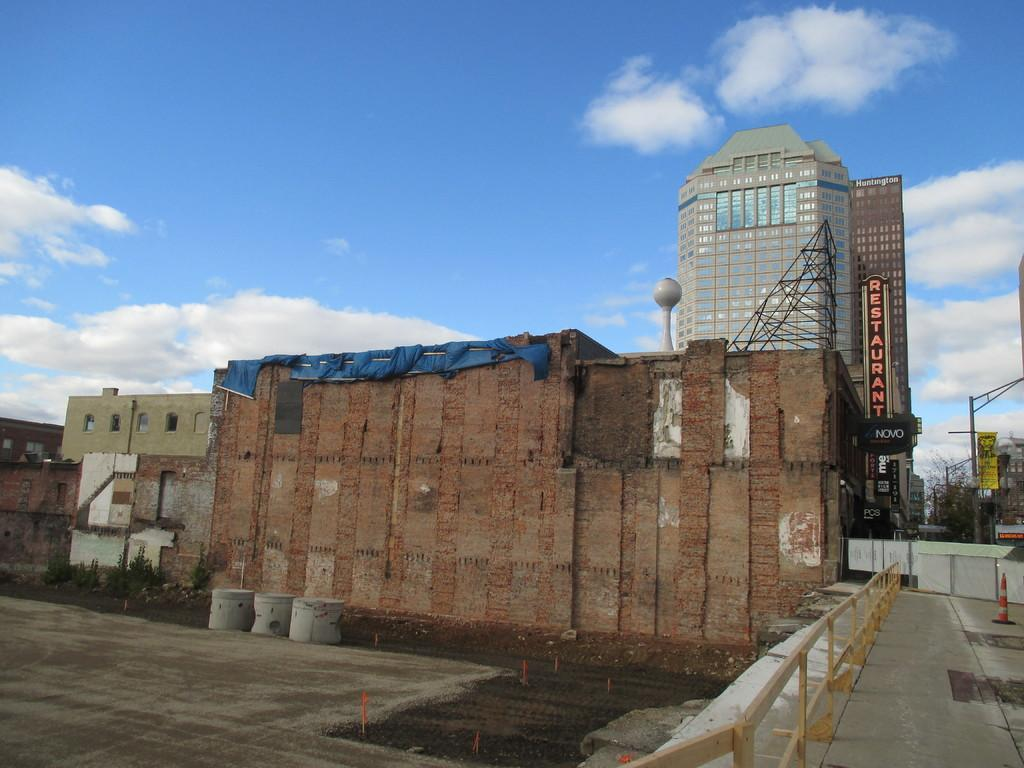What type of structures can be seen in the image? There are buildings in the image. What natural elements are present in the image? There are trees in the image. What man-made objects can be seen in the image? There are poles in the image. What object is located on the right side of the image? There is a traffic cone on the right side of the image. What type of flat objects are present in the image? There are boards in the image. What is visible in the background of the image? The sky is visible in the background of the image. What is the grandfather saying in the image? There is no grandfather present in the image, so it is not possible to determine what he might be saying. 